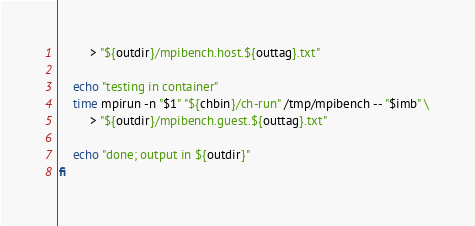Convert code to text. <code><loc_0><loc_0><loc_500><loc_500><_Bash_>         > "${outdir}/mpibench.host.${outtag}.txt"

    echo "testing in container"
    time mpirun -n "$1" "${chbin}/ch-run" /tmp/mpibench -- "$imb" \
         > "${outdir}/mpibench.guest.${outtag}.txt"

    echo "done; output in ${outdir}"
fi
</code> 